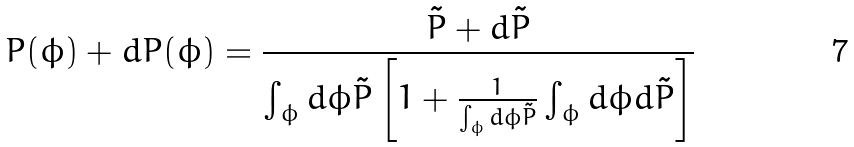<formula> <loc_0><loc_0><loc_500><loc_500>P ( \phi ) + d P ( \phi ) = \frac { \tilde { P } + d \tilde { P } } { \int _ { \phi } d \phi \tilde { P } \left [ 1 + \frac { 1 } { \int _ { \phi } d \phi \tilde { P } } \int _ { \phi } d \phi d \tilde { P } \right ] }</formula> 